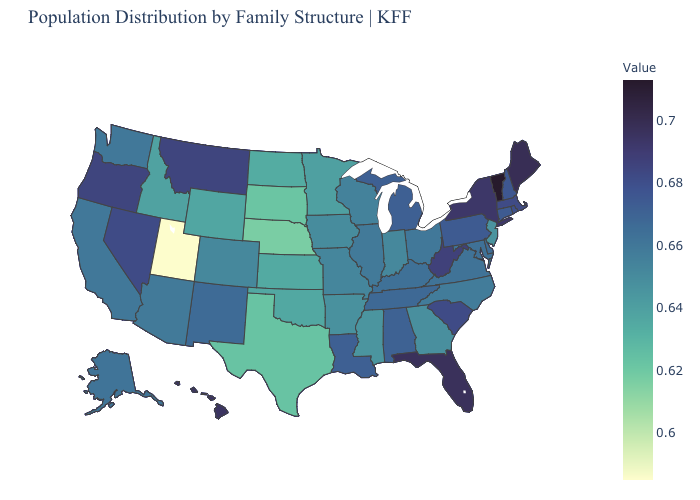Among the states that border Wyoming , does Utah have the lowest value?
Keep it brief. Yes. Is the legend a continuous bar?
Quick response, please. Yes. Which states have the highest value in the USA?
Keep it brief. Vermont. Does Utah have the lowest value in the USA?
Answer briefly. Yes. Does Nebraska have the lowest value in the MidWest?
Keep it brief. Yes. Which states have the lowest value in the MidWest?
Quick response, please. Nebraska. Among the states that border Tennessee , which have the highest value?
Keep it brief. Alabama. Does Wisconsin have a higher value than Florida?
Be succinct. No. 